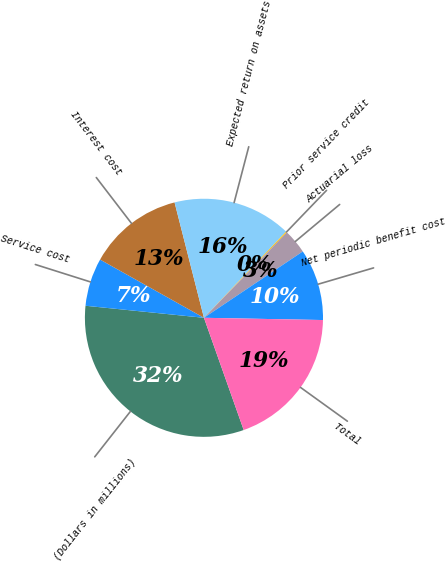Convert chart to OTSL. <chart><loc_0><loc_0><loc_500><loc_500><pie_chart><fcel>(Dollars in millions)<fcel>Service cost<fcel>Interest cost<fcel>Expected return on assets<fcel>Prior service credit<fcel>Actuarial loss<fcel>Net periodic benefit cost<fcel>Total<nl><fcel>32.03%<fcel>6.52%<fcel>12.9%<fcel>16.09%<fcel>0.14%<fcel>3.33%<fcel>9.71%<fcel>19.28%<nl></chart> 